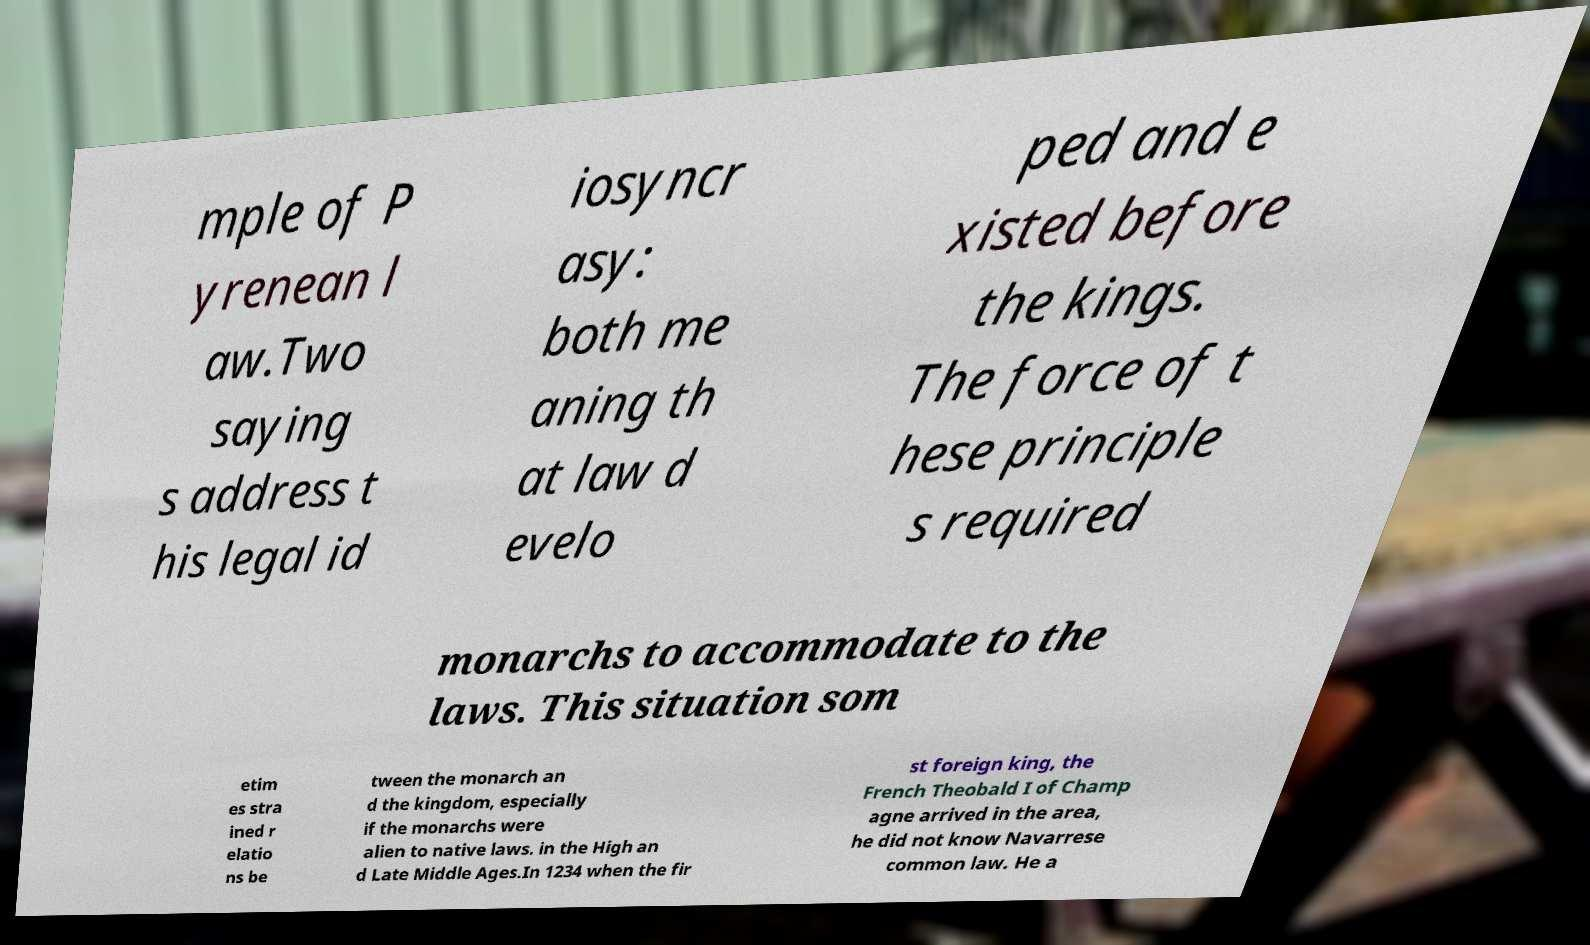There's text embedded in this image that I need extracted. Can you transcribe it verbatim? mple of P yrenean l aw.Two saying s address t his legal id iosyncr asy: both me aning th at law d evelo ped and e xisted before the kings. The force of t hese principle s required monarchs to accommodate to the laws. This situation som etim es stra ined r elatio ns be tween the monarch an d the kingdom, especially if the monarchs were alien to native laws. in the High an d Late Middle Ages.In 1234 when the fir st foreign king, the French Theobald I of Champ agne arrived in the area, he did not know Navarrese common law. He a 